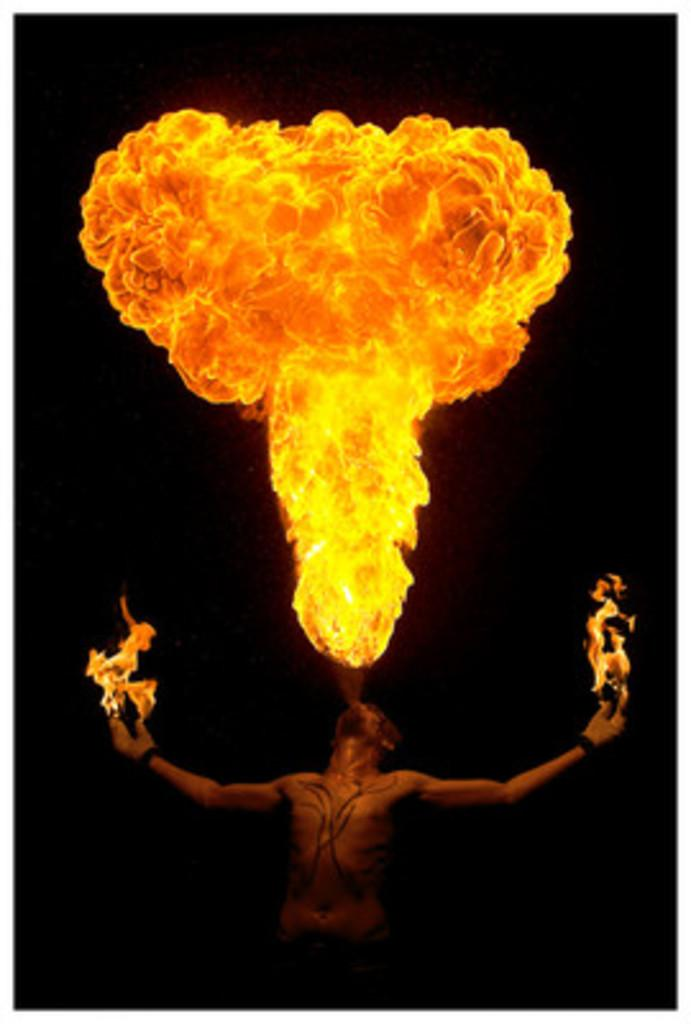What is the main subject of the image? There is a person standing in the image. What else can be seen in the image besides the person? There is fire in the image. How would you describe the overall appearance of the image? The background of the image is dark. What type of clouds can be seen in the image? There are no clouds present in the image; it features a person and fire with a dark background. How does the taste of the snails affect the person in the image? There are no snails or any indication of taste in the image; it only shows a person and fire with a dark background. 